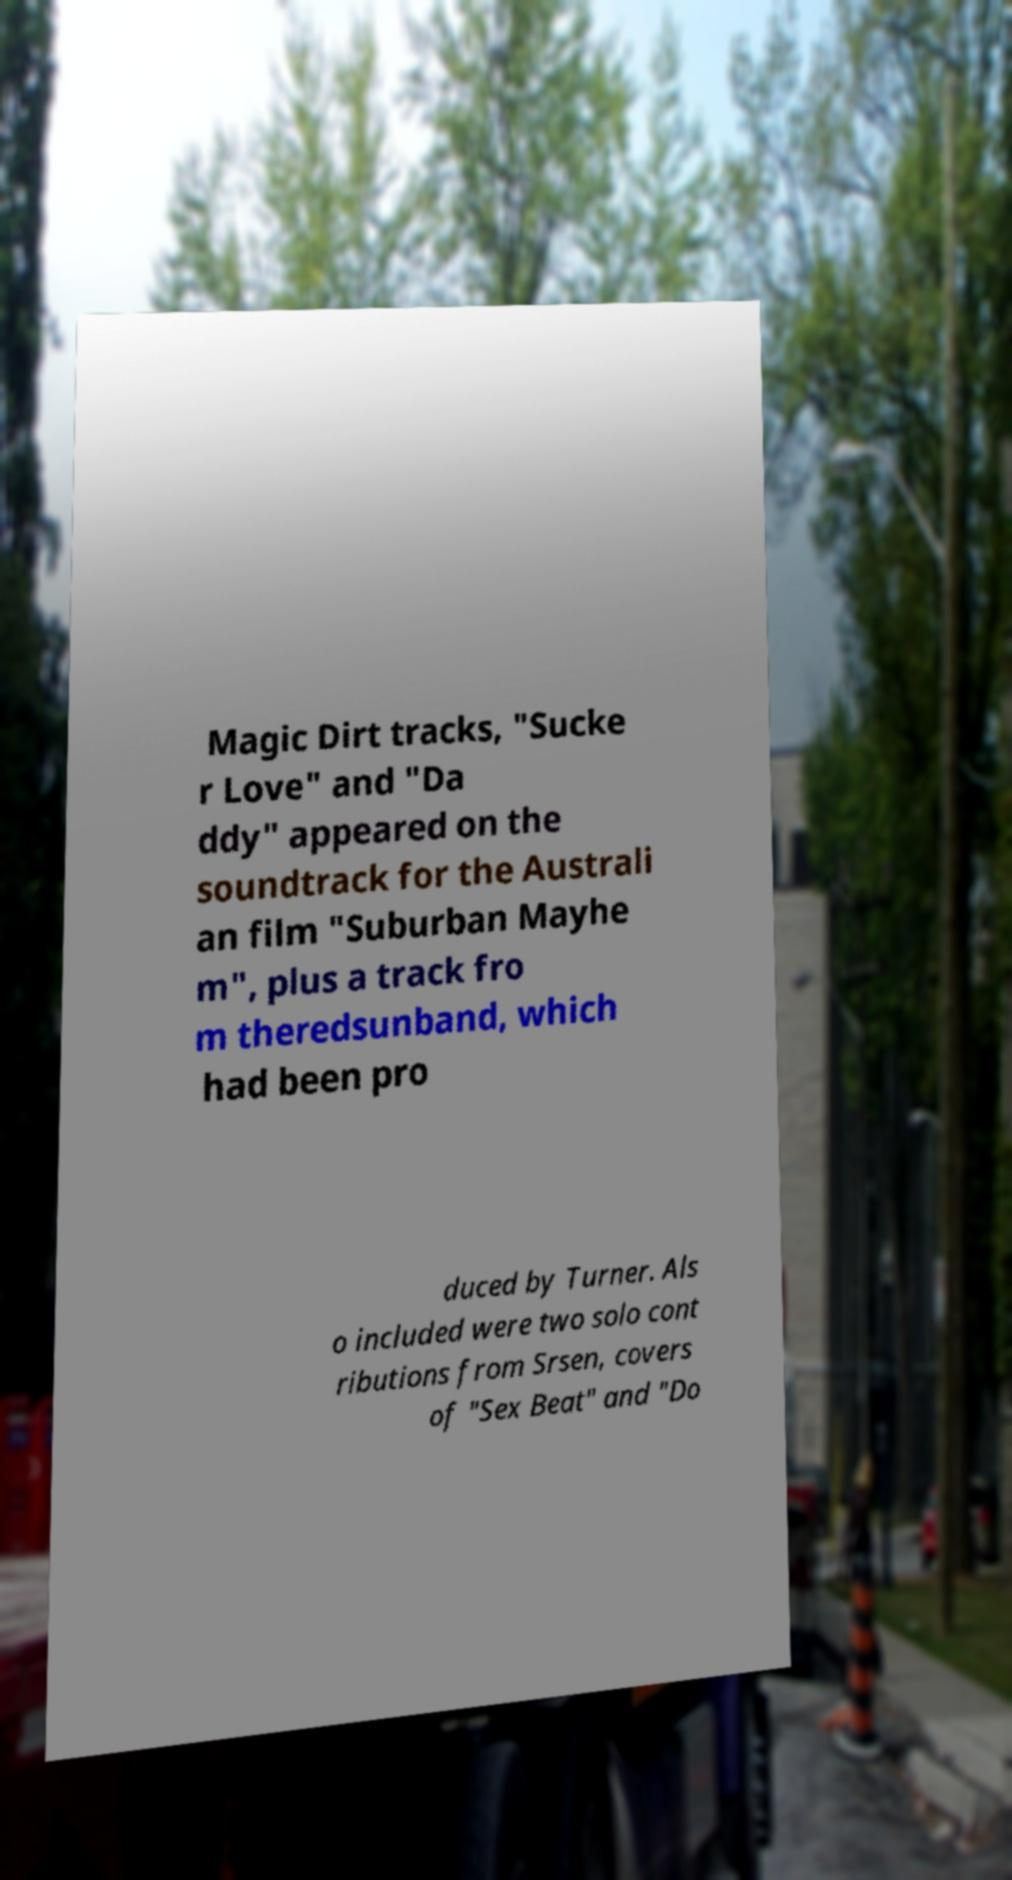Could you extract and type out the text from this image? Magic Dirt tracks, "Sucke r Love" and "Da ddy" appeared on the soundtrack for the Australi an film "Suburban Mayhe m", plus a track fro m theredsunband, which had been pro duced by Turner. Als o included were two solo cont ributions from Srsen, covers of "Sex Beat" and "Do 